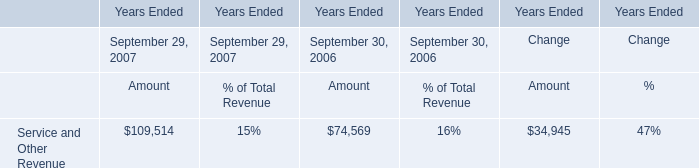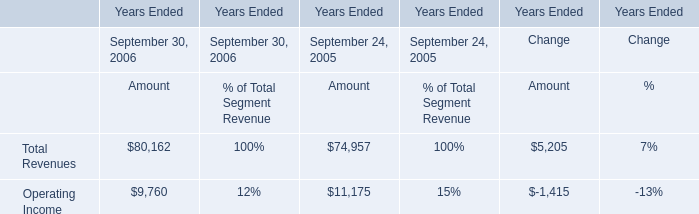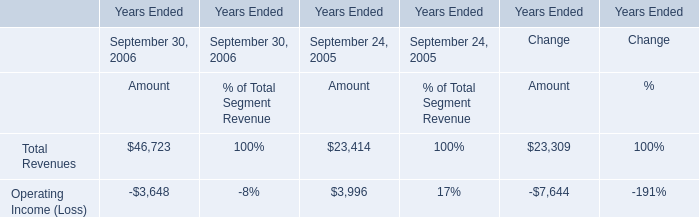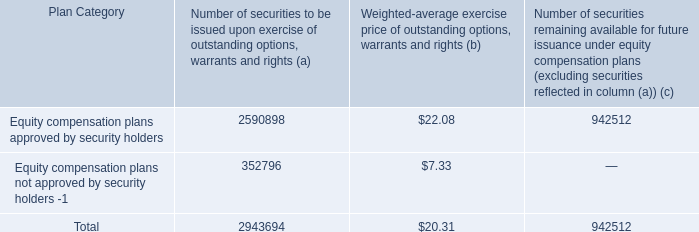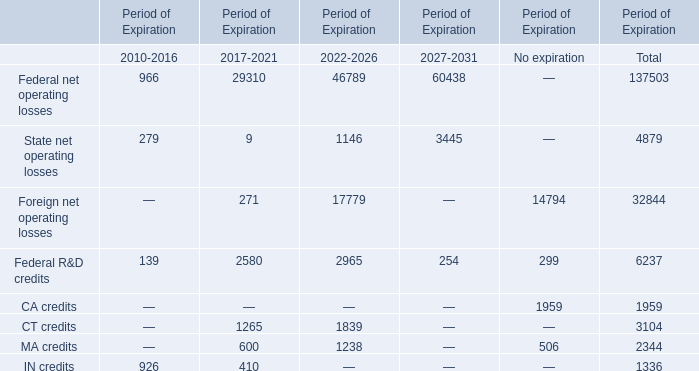What was the 50% of the Foreign net operating losses for the Period of Expiration 2022-2026? 
Computations: (0.5 * 17779)
Answer: 8889.5. 